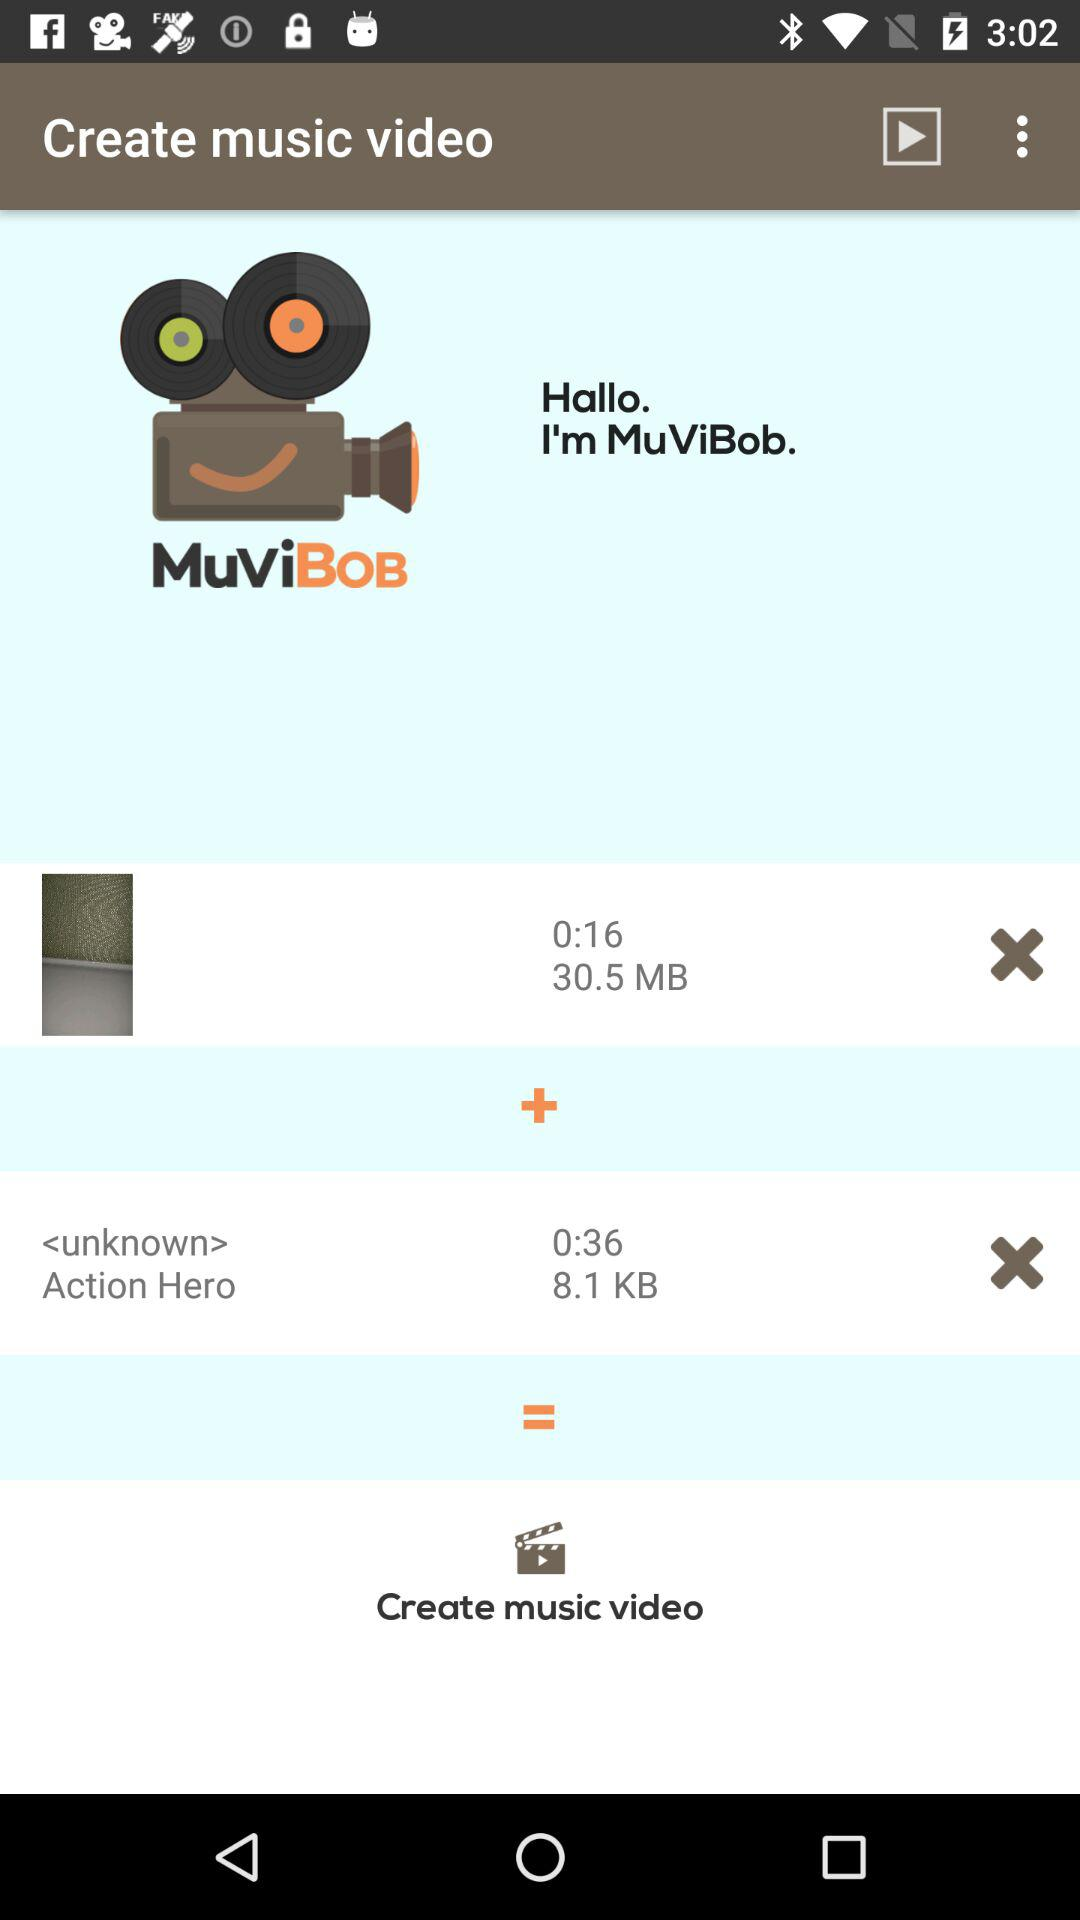What is the size of the "Action Hero" video? The size is 8.1 KB. 